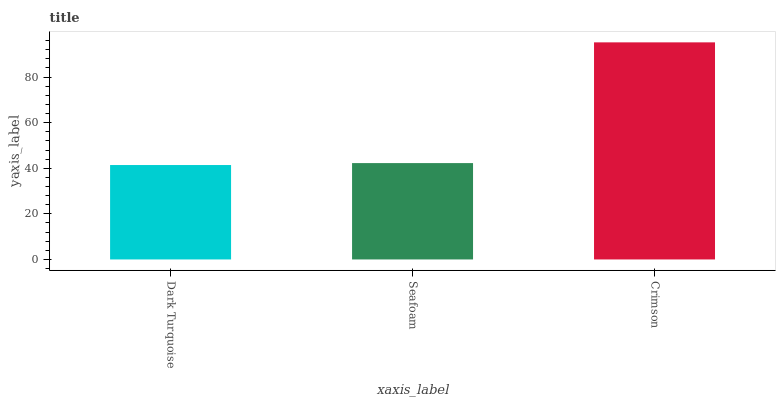Is Seafoam the minimum?
Answer yes or no. No. Is Seafoam the maximum?
Answer yes or no. No. Is Seafoam greater than Dark Turquoise?
Answer yes or no. Yes. Is Dark Turquoise less than Seafoam?
Answer yes or no. Yes. Is Dark Turquoise greater than Seafoam?
Answer yes or no. No. Is Seafoam less than Dark Turquoise?
Answer yes or no. No. Is Seafoam the high median?
Answer yes or no. Yes. Is Seafoam the low median?
Answer yes or no. Yes. Is Dark Turquoise the high median?
Answer yes or no. No. Is Crimson the low median?
Answer yes or no. No. 